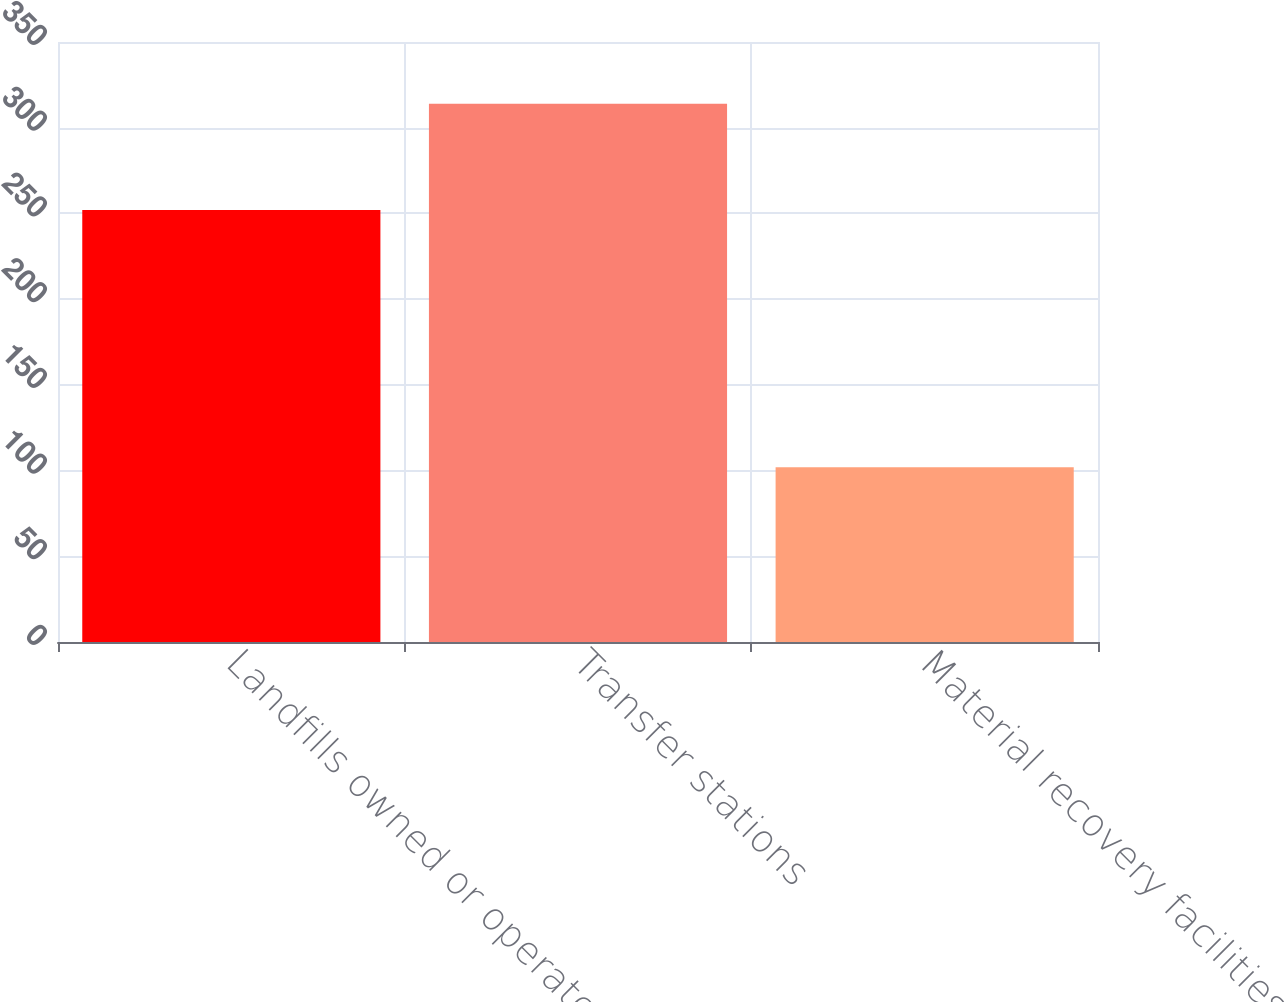Convert chart. <chart><loc_0><loc_0><loc_500><loc_500><bar_chart><fcel>Landfills owned or operated<fcel>Transfer stations<fcel>Material recovery facilities<nl><fcel>252<fcel>314<fcel>102<nl></chart> 